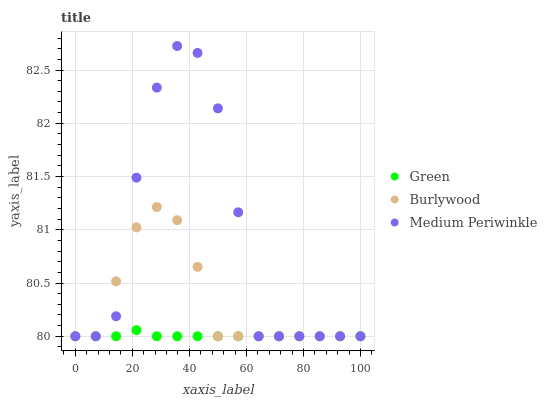Does Green have the minimum area under the curve?
Answer yes or no. Yes. Does Medium Periwinkle have the maximum area under the curve?
Answer yes or no. Yes. Does Medium Periwinkle have the minimum area under the curve?
Answer yes or no. No. Does Green have the maximum area under the curve?
Answer yes or no. No. Is Green the smoothest?
Answer yes or no. Yes. Is Medium Periwinkle the roughest?
Answer yes or no. Yes. Is Medium Periwinkle the smoothest?
Answer yes or no. No. Is Green the roughest?
Answer yes or no. No. Does Burlywood have the lowest value?
Answer yes or no. Yes. Does Medium Periwinkle have the highest value?
Answer yes or no. Yes. Does Green have the highest value?
Answer yes or no. No. Does Burlywood intersect Green?
Answer yes or no. Yes. Is Burlywood less than Green?
Answer yes or no. No. Is Burlywood greater than Green?
Answer yes or no. No. 